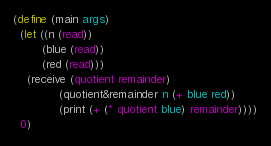<code> <loc_0><loc_0><loc_500><loc_500><_Scheme_>(define (main args)
  (let ((n (read))
        (blue (read))
        (red (read)))
    (receive (quotient remainder)
             (quotient&remainder n (+ blue red))
             (print (+ (* quotient blue) remainder))))
  0)
</code> 